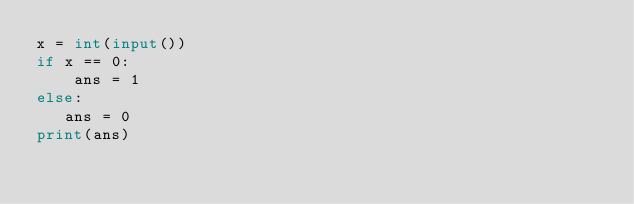<code> <loc_0><loc_0><loc_500><loc_500><_Python_>x = int(input())
if x == 0:
    ans = 1
else:
   ans = 0
print(ans)</code> 